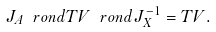Convert formula to latex. <formula><loc_0><loc_0><loc_500><loc_500>J _ { A } \ r o n d T V \ r o n d J _ { X } ^ { - 1 } = T V .</formula> 